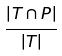<formula> <loc_0><loc_0><loc_500><loc_500>\frac { | T \cap P | } { | T | }</formula> 